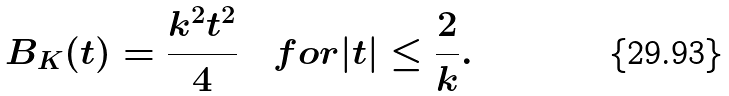Convert formula to latex. <formula><loc_0><loc_0><loc_500><loc_500>B _ { K } ( t ) = \frac { k ^ { 2 } t ^ { 2 } } { 4 } \quad f o r | t | \leq \frac { 2 } { k } .</formula> 